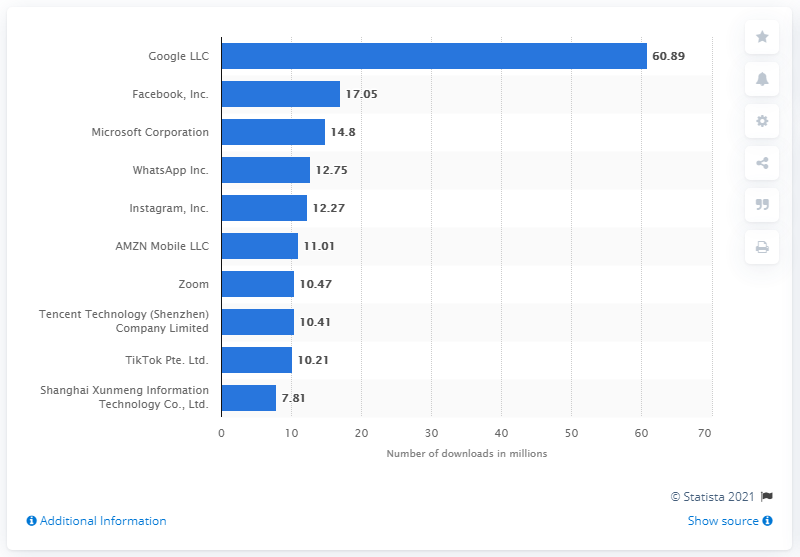List a handful of essential elements in this visual. In 2021, the top non-gaming iPhone app publisher was Google LLC. In January 2021, Google had 60.89 million app downloads by iPhone users. In January 2021, Facebook generated 17.05 million iPhone app downloads. 